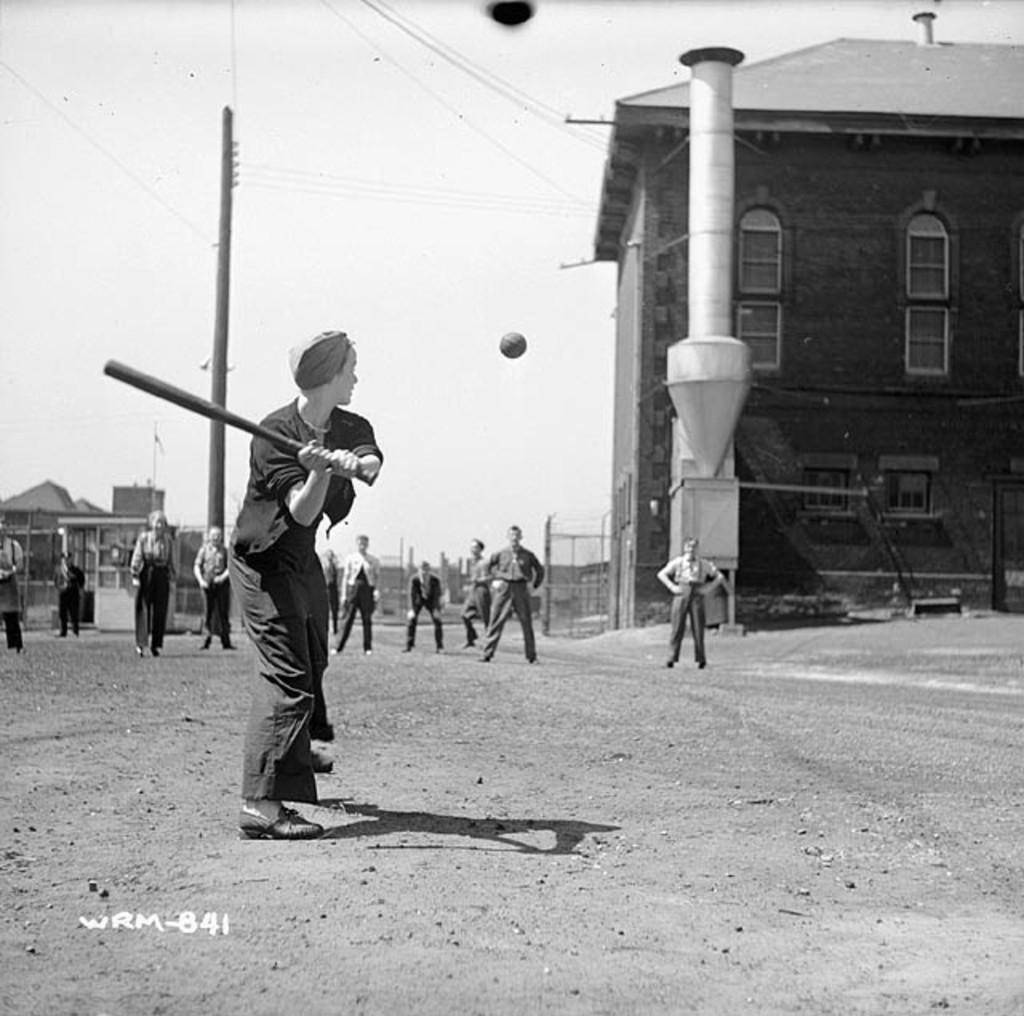Could you give a brief overview of what you see in this image? In this picture there is a person, by holding a bat on the left side of the image and there is a ball in the center of the image and there are people in the background area of the image, it seems to be they are playing and there are houses and poles in the background area of the image, it seems to be there is a chimney in front of a house. 